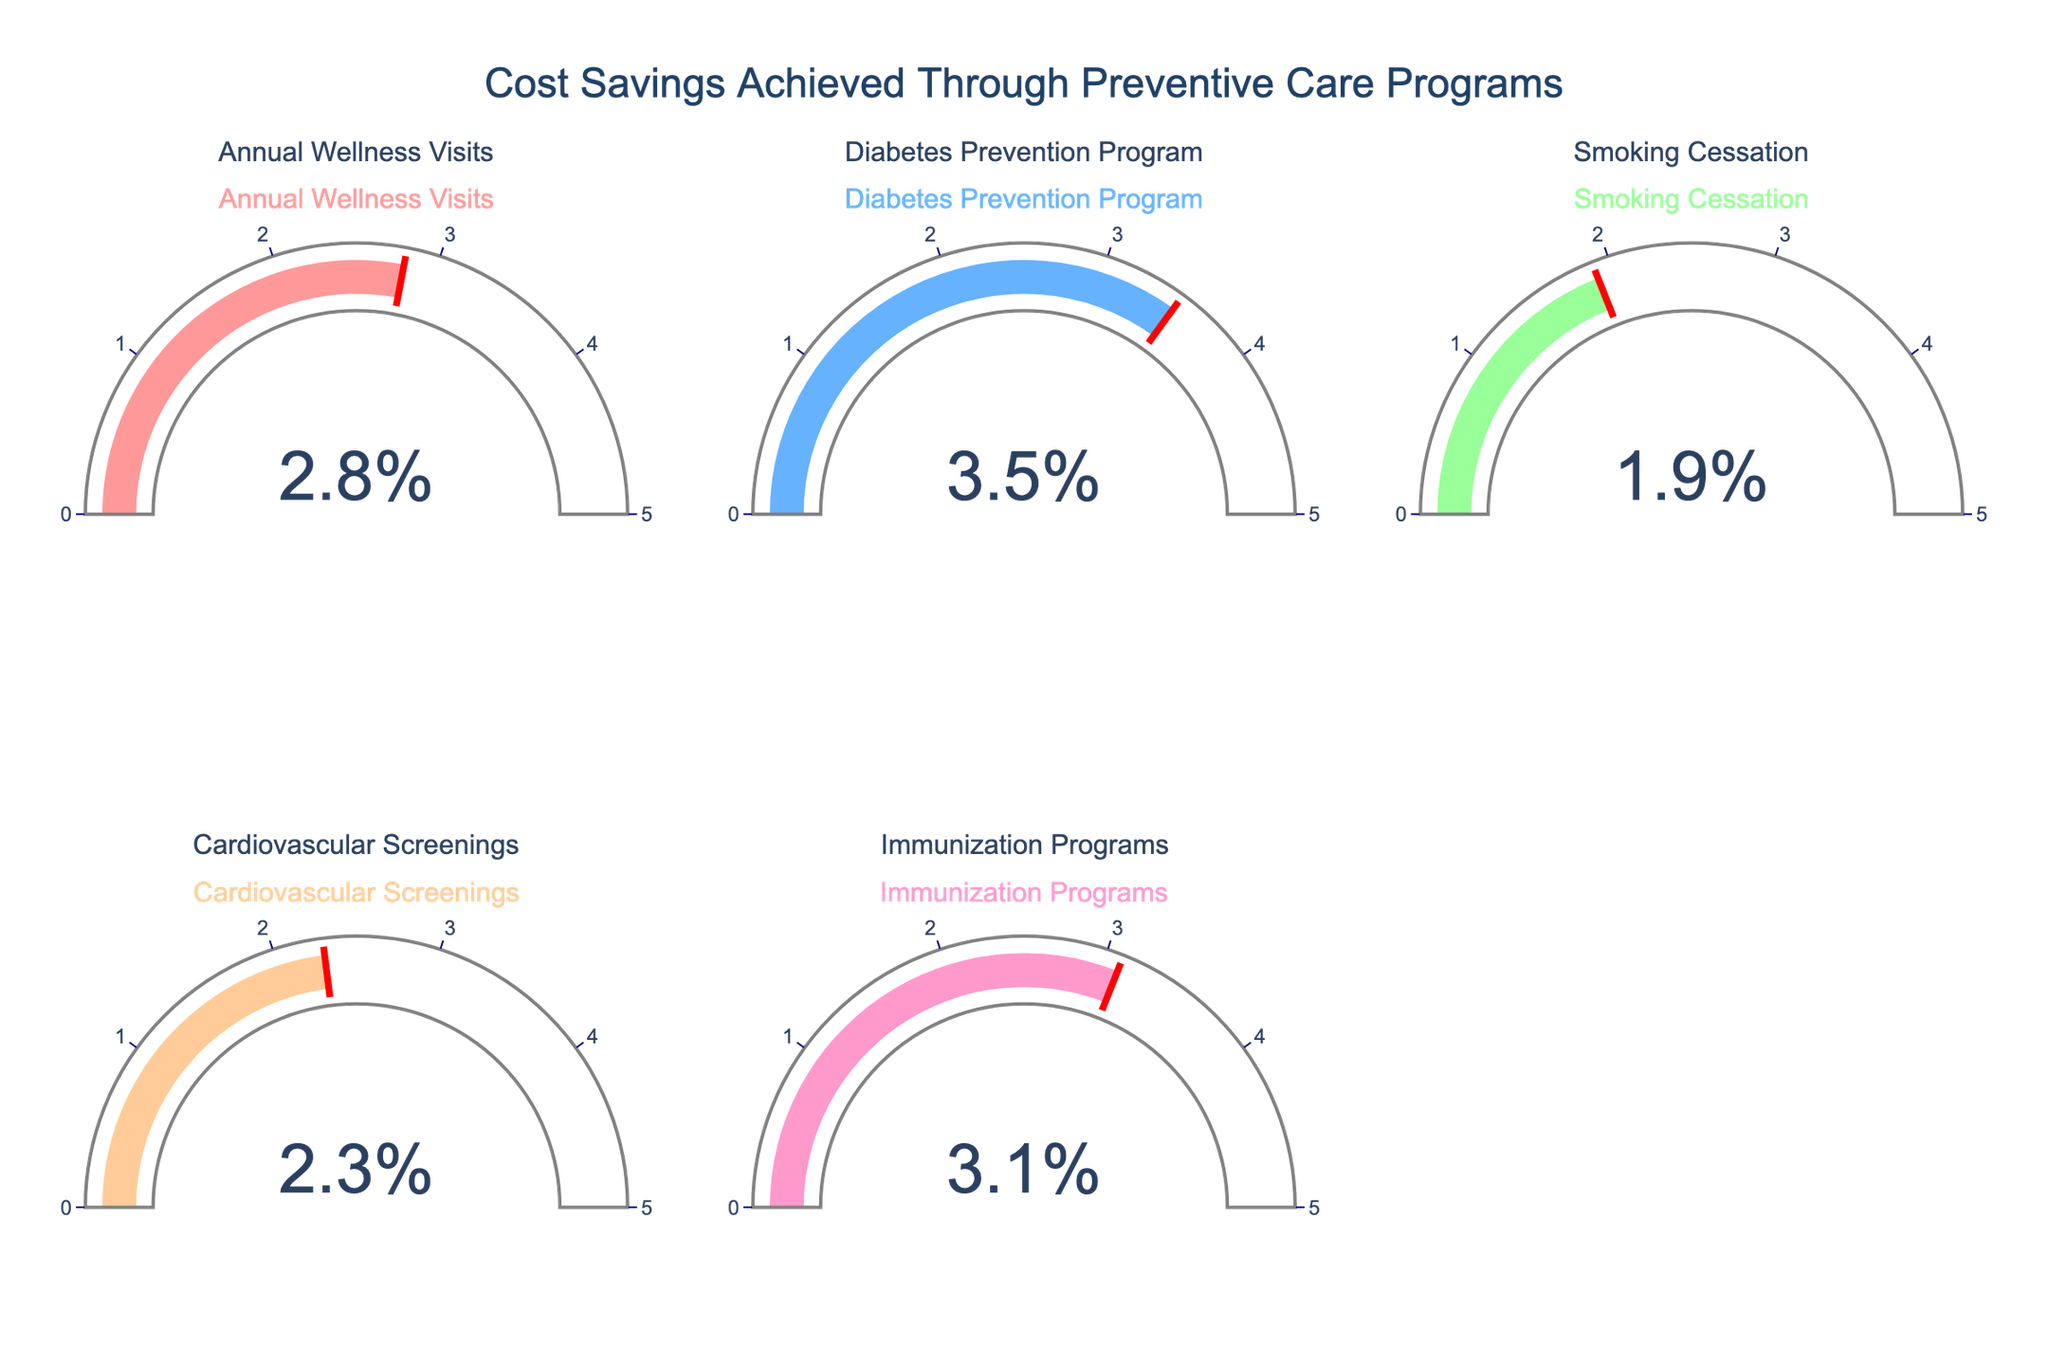What is the cost savings percentage for the Diabetes Prevention Program? Look at the gauge chart corresponding to the Diabetes Prevention Program and read the number displayed.
Answer: 3.5% Which preventive care program achieved the highest cost savings percentage? Compare the values on all gauges and identify the highest number.
Answer: Diabetes Prevention Program How does the cost savings percentage of Immunization Programs compare to Annual Wellness Visits? Find the values for both Immunization Programs and Annual Wellness Visits and compare them; Immunization Programs have 3.1% while Annual Wellness Visits have 2.8%.
Answer: Immunization Programs have a higher percentage What is the average cost savings percentage of all presented preventive care programs? Sum all the percentages and divide by the number of programs: (2.8 + 3.5 + 1.9 + 2.3 + 3.1) / 5.
Answer: 2.72% Which program has the lowest cost savings percentage? Compare the values on all gauges and identify the lowest number.
Answer: Smoking Cessation How much higher is the cost savings percentage of Diabetes Prevention Program compared to Smoking Cessation? Subtract the percentage of Smoking Cessation from the Diabetes Prevention Program (3.5% - 1.9%).
Answer: 1.6% What is the combined cost savings percentage for Cardiovascular Screenings and Immunization Programs? Add the percentages of Cardiovascular Screenings and Immunization Programs: 2.3% + 3.1%.
Answer: 5.4% Are there any programs that achieve exactly a 3% cost savings? Check the displayed percentages on all gauges to see if any show 3%.
Answer: No How much more cost savings does the Immunization Programs achieve compared to the Annual Wellness Visits and Cardiovascular Screenings combined? First, sum the percentages of Annual Wellness Visits and Cardiovascular Screenings: 2.8% + 2.3% = 5.1%. Then, subtract this sum from Immunization Programs' percentage: 5.1% - 3.1%.
Answer: -2.0% (indicating Immunization Programs achieve less) What's the range of cost savings percentages among all preventive care programs? Identify the highest and lowest percentages: highest is 3.5% (Diabetes Prevention Program) and lowest is 1.9% (Smoking Cessation). Subtract the lowest from the highest: 3.5% - 1.9%.
Answer: 1.6% 